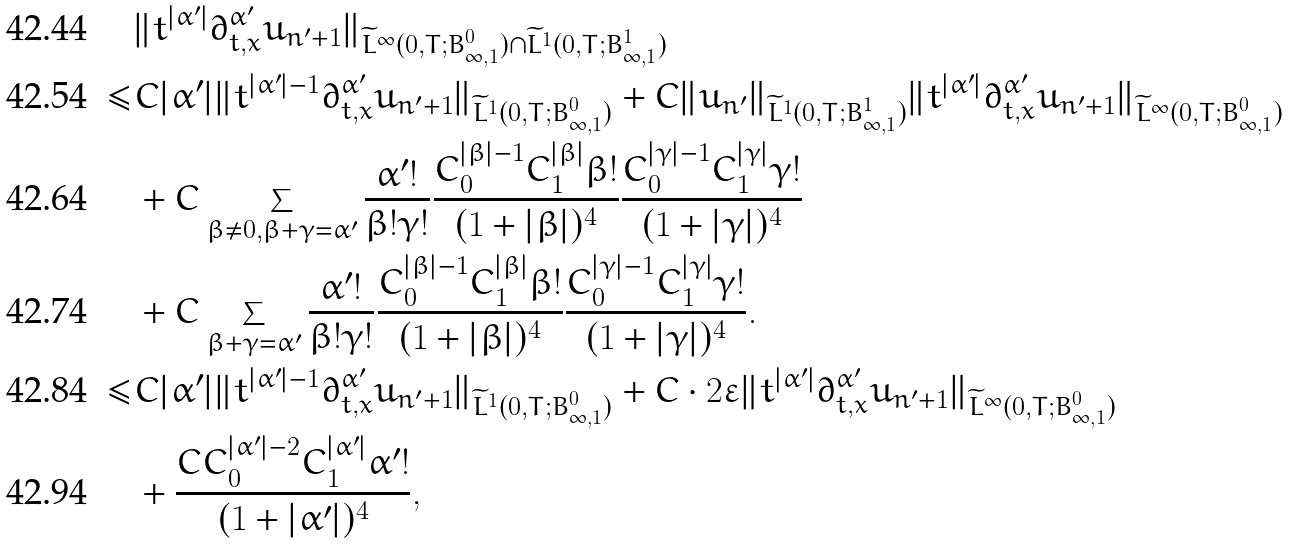Convert formula to latex. <formula><loc_0><loc_0><loc_500><loc_500>& \| t ^ { | \alpha ^ { \prime } | } \partial _ { t , x } ^ { \alpha ^ { \prime } } u _ { n ^ { \prime } + 1 } \| _ { \widetilde { L } ^ { \infty } ( 0 , T ; B ^ { 0 } _ { \infty , 1 } ) \cap \widetilde { L } ^ { 1 } ( 0 , T ; B ^ { 1 } _ { \infty , 1 } ) } \\ \leq & C | \alpha ^ { \prime } | \| t ^ { | \alpha ^ { \prime } | - 1 } \partial _ { t , x } ^ { \alpha ^ { \prime } } u _ { n ^ { \prime } + 1 } \| _ { \widetilde { L } ^ { 1 } ( 0 , T ; B ^ { 0 } _ { \infty , 1 } ) } + C \| u _ { n ^ { \prime } } \| _ { \widetilde { L } ^ { 1 } ( 0 , T ; B ^ { 1 } _ { \infty , 1 } ) } \| t ^ { | \alpha ^ { \prime } | } \partial _ { t , x } ^ { \alpha ^ { \prime } } u _ { n ^ { \prime } + 1 } \| _ { \widetilde { L } ^ { \infty } ( 0 , T ; B ^ { 0 } _ { \infty , 1 } ) } \\ & + C \sum _ { \beta \not = 0 , \beta + \gamma = \alpha ^ { \prime } } \frac { \alpha ^ { \prime } ! } { \beta ! \gamma ! } \frac { C _ { 0 } ^ { | \beta | - 1 } C _ { 1 } ^ { | \beta | } \beta ! } { ( 1 + | \beta | ) ^ { 4 } } \frac { C _ { 0 } ^ { | \gamma | - 1 } C _ { 1 } ^ { | \gamma | } \gamma ! } { ( 1 + | \gamma | ) ^ { 4 } } \\ & + C \sum _ { \beta + \gamma = \alpha ^ { \prime } } \frac { \alpha ^ { \prime } ! } { \beta ! \gamma ! } \frac { C _ { 0 } ^ { | \beta | - 1 } C _ { 1 } ^ { | \beta | } \beta ! } { ( 1 + | \beta | ) ^ { 4 } } \frac { C _ { 0 } ^ { | \gamma | - 1 } C _ { 1 } ^ { | \gamma | } \gamma ! } { ( 1 + | \gamma | ) ^ { 4 } } . \\ \leq & C | \alpha ^ { \prime } | \| t ^ { | \alpha ^ { \prime } | - 1 } \partial _ { t , x } ^ { \alpha ^ { \prime } } u _ { n ^ { \prime } + 1 } \| _ { \widetilde { L } ^ { 1 } ( 0 , T ; B ^ { 0 } _ { \infty , 1 } ) } + C \cdot 2 \varepsilon \| t ^ { | \alpha ^ { \prime } | } \partial _ { t , x } ^ { \alpha ^ { \prime } } u _ { n ^ { \prime } + 1 } \| _ { \widetilde { L } ^ { \infty } ( 0 , T ; B ^ { 0 } _ { \infty , 1 } ) } \\ & + \frac { C C _ { 0 } ^ { | \alpha ^ { \prime } | - 2 } C _ { 1 } ^ { | \alpha ^ { \prime } | } \alpha ^ { \prime } ! } { ( 1 + | \alpha ^ { \prime } | ) ^ { 4 } } ,</formula> 